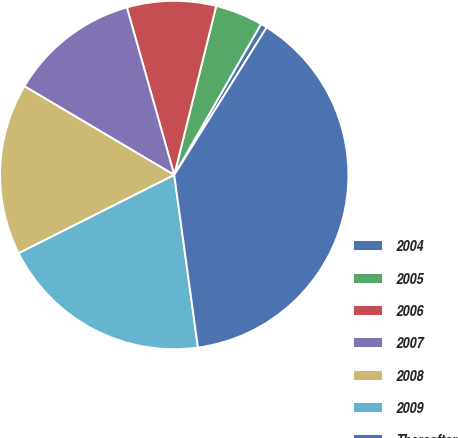<chart> <loc_0><loc_0><loc_500><loc_500><pie_chart><fcel>2004<fcel>2005<fcel>2006<fcel>2007<fcel>2008<fcel>2009<fcel>Thereafter<nl><fcel>0.6%<fcel>4.43%<fcel>8.26%<fcel>12.1%<fcel>15.93%<fcel>19.76%<fcel>38.92%<nl></chart> 